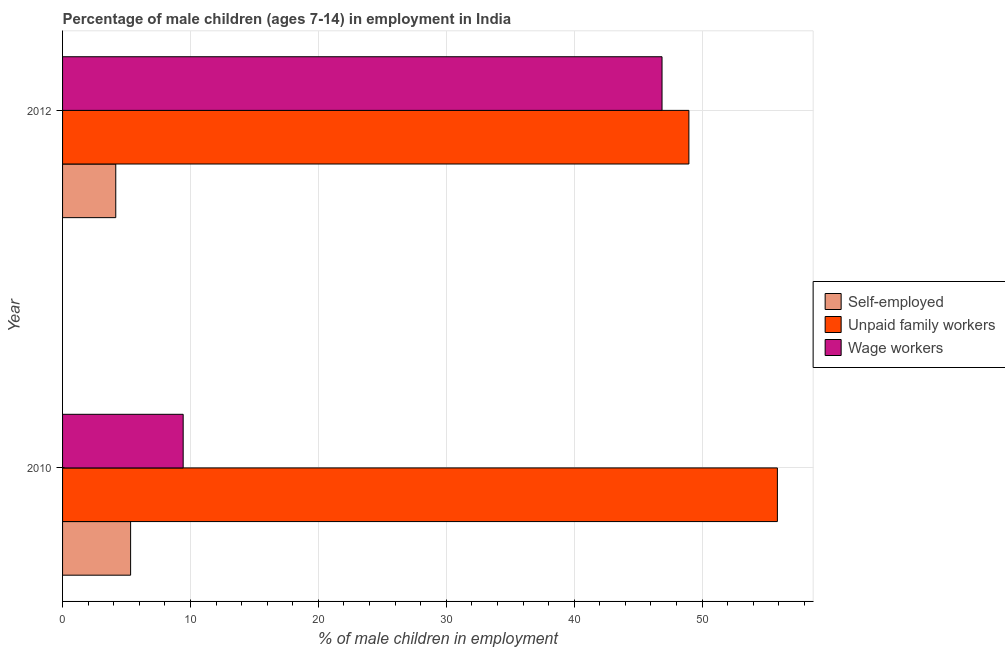How many different coloured bars are there?
Your answer should be very brief. 3. How many bars are there on the 2nd tick from the top?
Provide a short and direct response. 3. What is the label of the 1st group of bars from the top?
Ensure brevity in your answer.  2012. In how many cases, is the number of bars for a given year not equal to the number of legend labels?
Your answer should be very brief. 0. What is the percentage of children employed as unpaid family workers in 2012?
Keep it short and to the point. 48.97. Across all years, what is the maximum percentage of self employed children?
Offer a very short reply. 5.32. Across all years, what is the minimum percentage of children employed as wage workers?
Ensure brevity in your answer.  9.43. In which year was the percentage of self employed children minimum?
Your response must be concise. 2012. What is the total percentage of self employed children in the graph?
Offer a terse response. 9.48. What is the difference between the percentage of children employed as unpaid family workers in 2010 and that in 2012?
Your answer should be very brief. 6.92. What is the difference between the percentage of self employed children in 2010 and the percentage of children employed as wage workers in 2012?
Give a very brief answer. -41.55. What is the average percentage of children employed as unpaid family workers per year?
Offer a very short reply. 52.43. In the year 2010, what is the difference between the percentage of children employed as unpaid family workers and percentage of children employed as wage workers?
Provide a succinct answer. 46.46. What is the ratio of the percentage of self employed children in 2010 to that in 2012?
Your response must be concise. 1.28. Is the percentage of children employed as unpaid family workers in 2010 less than that in 2012?
Provide a short and direct response. No. Is the difference between the percentage of self employed children in 2010 and 2012 greater than the difference between the percentage of children employed as unpaid family workers in 2010 and 2012?
Your answer should be compact. No. What does the 2nd bar from the top in 2012 represents?
Ensure brevity in your answer.  Unpaid family workers. What does the 1st bar from the bottom in 2012 represents?
Provide a succinct answer. Self-employed. How many bars are there?
Your response must be concise. 6. Are all the bars in the graph horizontal?
Keep it short and to the point. Yes. How many years are there in the graph?
Offer a very short reply. 2. Are the values on the major ticks of X-axis written in scientific E-notation?
Provide a short and direct response. No. Does the graph contain any zero values?
Ensure brevity in your answer.  No. Where does the legend appear in the graph?
Provide a succinct answer. Center right. How many legend labels are there?
Provide a short and direct response. 3. How are the legend labels stacked?
Keep it short and to the point. Vertical. What is the title of the graph?
Ensure brevity in your answer.  Percentage of male children (ages 7-14) in employment in India. Does "Fuel" appear as one of the legend labels in the graph?
Offer a terse response. No. What is the label or title of the X-axis?
Make the answer very short. % of male children in employment. What is the label or title of the Y-axis?
Your answer should be compact. Year. What is the % of male children in employment of Self-employed in 2010?
Provide a short and direct response. 5.32. What is the % of male children in employment in Unpaid family workers in 2010?
Offer a very short reply. 55.89. What is the % of male children in employment of Wage workers in 2010?
Keep it short and to the point. 9.43. What is the % of male children in employment in Self-employed in 2012?
Provide a short and direct response. 4.16. What is the % of male children in employment in Unpaid family workers in 2012?
Offer a terse response. 48.97. What is the % of male children in employment in Wage workers in 2012?
Offer a very short reply. 46.87. Across all years, what is the maximum % of male children in employment in Self-employed?
Your response must be concise. 5.32. Across all years, what is the maximum % of male children in employment of Unpaid family workers?
Provide a succinct answer. 55.89. Across all years, what is the maximum % of male children in employment of Wage workers?
Provide a succinct answer. 46.87. Across all years, what is the minimum % of male children in employment of Self-employed?
Keep it short and to the point. 4.16. Across all years, what is the minimum % of male children in employment of Unpaid family workers?
Your answer should be very brief. 48.97. Across all years, what is the minimum % of male children in employment in Wage workers?
Keep it short and to the point. 9.43. What is the total % of male children in employment in Self-employed in the graph?
Give a very brief answer. 9.48. What is the total % of male children in employment in Unpaid family workers in the graph?
Give a very brief answer. 104.86. What is the total % of male children in employment of Wage workers in the graph?
Make the answer very short. 56.3. What is the difference between the % of male children in employment in Self-employed in 2010 and that in 2012?
Your response must be concise. 1.16. What is the difference between the % of male children in employment in Unpaid family workers in 2010 and that in 2012?
Keep it short and to the point. 6.92. What is the difference between the % of male children in employment of Wage workers in 2010 and that in 2012?
Ensure brevity in your answer.  -37.44. What is the difference between the % of male children in employment of Self-employed in 2010 and the % of male children in employment of Unpaid family workers in 2012?
Provide a short and direct response. -43.65. What is the difference between the % of male children in employment in Self-employed in 2010 and the % of male children in employment in Wage workers in 2012?
Your answer should be compact. -41.55. What is the difference between the % of male children in employment of Unpaid family workers in 2010 and the % of male children in employment of Wage workers in 2012?
Offer a terse response. 9.02. What is the average % of male children in employment of Self-employed per year?
Make the answer very short. 4.74. What is the average % of male children in employment in Unpaid family workers per year?
Your answer should be very brief. 52.43. What is the average % of male children in employment of Wage workers per year?
Ensure brevity in your answer.  28.15. In the year 2010, what is the difference between the % of male children in employment of Self-employed and % of male children in employment of Unpaid family workers?
Make the answer very short. -50.57. In the year 2010, what is the difference between the % of male children in employment in Self-employed and % of male children in employment in Wage workers?
Offer a very short reply. -4.11. In the year 2010, what is the difference between the % of male children in employment of Unpaid family workers and % of male children in employment of Wage workers?
Your response must be concise. 46.46. In the year 2012, what is the difference between the % of male children in employment of Self-employed and % of male children in employment of Unpaid family workers?
Keep it short and to the point. -44.81. In the year 2012, what is the difference between the % of male children in employment of Self-employed and % of male children in employment of Wage workers?
Your response must be concise. -42.71. What is the ratio of the % of male children in employment in Self-employed in 2010 to that in 2012?
Your answer should be compact. 1.28. What is the ratio of the % of male children in employment in Unpaid family workers in 2010 to that in 2012?
Make the answer very short. 1.14. What is the ratio of the % of male children in employment of Wage workers in 2010 to that in 2012?
Make the answer very short. 0.2. What is the difference between the highest and the second highest % of male children in employment of Self-employed?
Offer a terse response. 1.16. What is the difference between the highest and the second highest % of male children in employment in Unpaid family workers?
Offer a terse response. 6.92. What is the difference between the highest and the second highest % of male children in employment in Wage workers?
Provide a succinct answer. 37.44. What is the difference between the highest and the lowest % of male children in employment of Self-employed?
Give a very brief answer. 1.16. What is the difference between the highest and the lowest % of male children in employment in Unpaid family workers?
Ensure brevity in your answer.  6.92. What is the difference between the highest and the lowest % of male children in employment in Wage workers?
Provide a short and direct response. 37.44. 